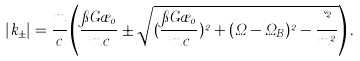Convert formula to latex. <formula><loc_0><loc_0><loc_500><loc_500>| k _ { \pm } | = \frac { m } { c } \left ( \frac { \pi G \rho _ { 0 } } { m c } \pm \sqrt { ( \frac { \pi G \rho _ { 0 } } { m c } ) ^ { 2 } + ( \Omega - \Omega _ { B } ) ^ { 2 } - \frac { \kappa ^ { 2 } } { m ^ { 2 } } } \right ) .</formula> 